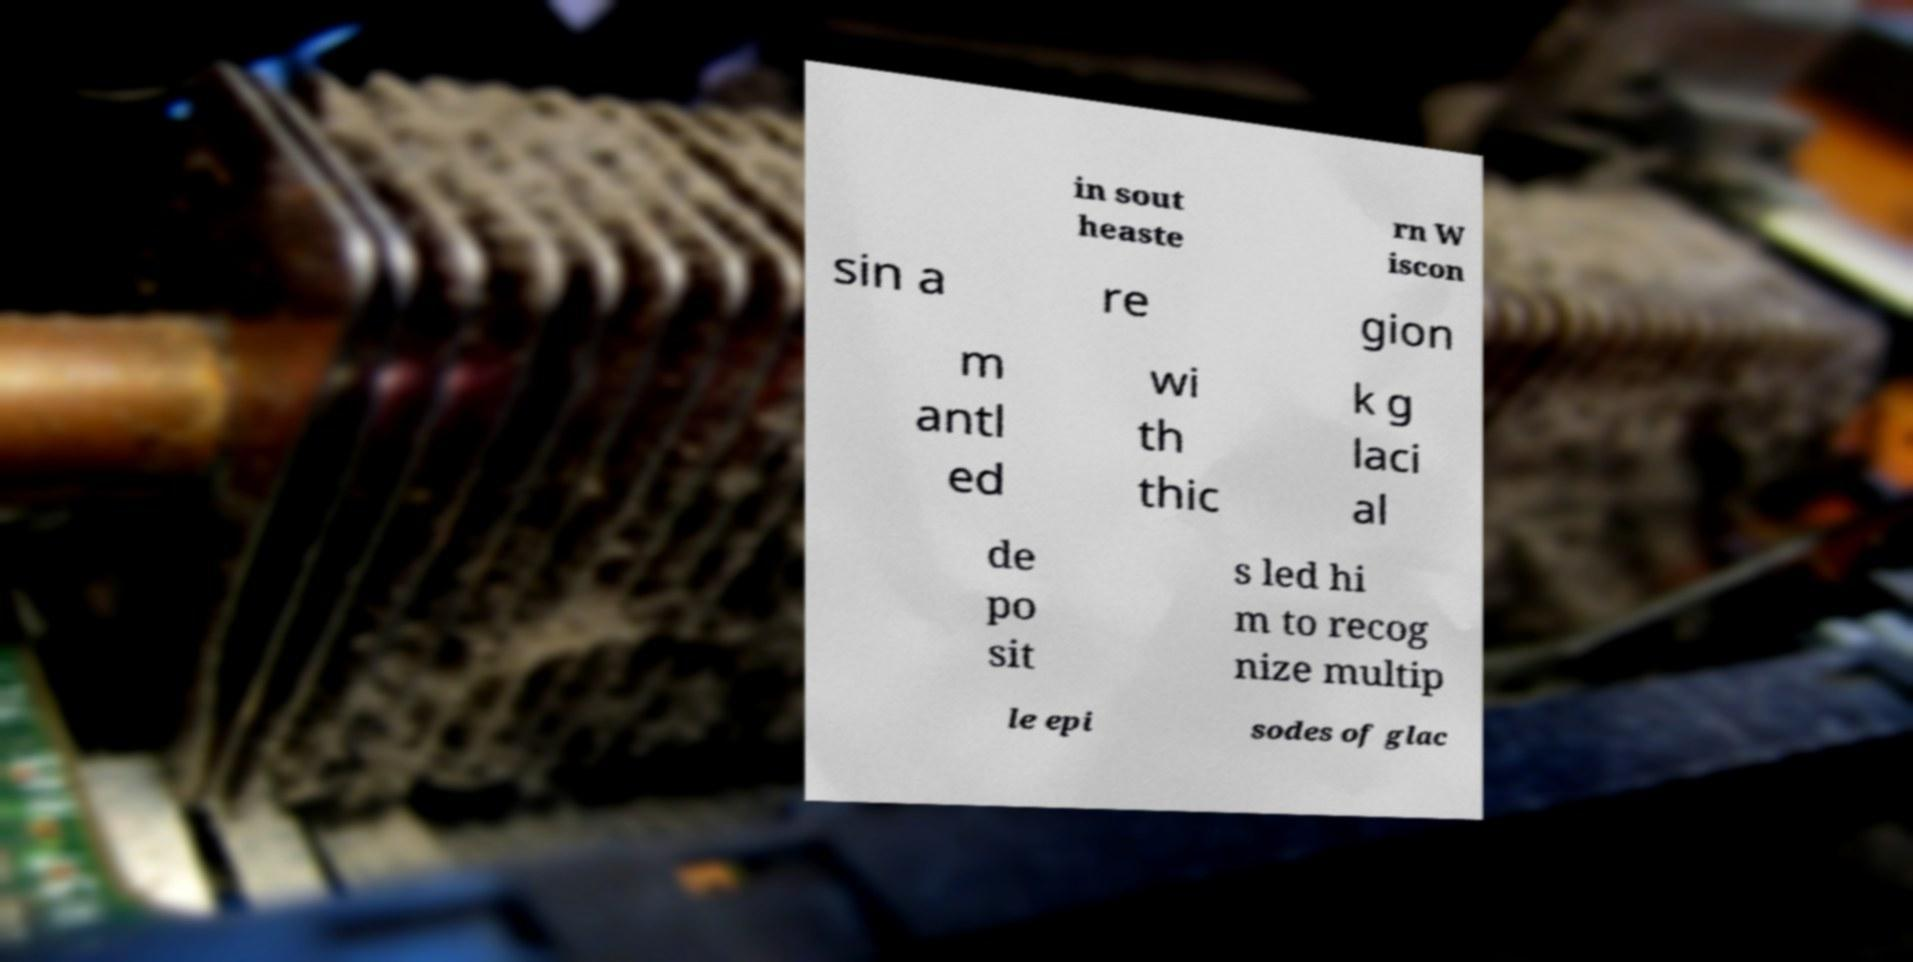Could you extract and type out the text from this image? in sout heaste rn W iscon sin a re gion m antl ed wi th thic k g laci al de po sit s led hi m to recog nize multip le epi sodes of glac 